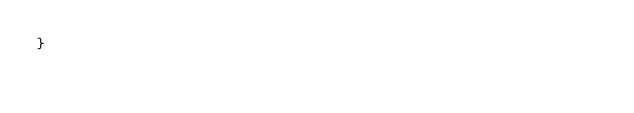<code> <loc_0><loc_0><loc_500><loc_500><_C_>}
</code> 